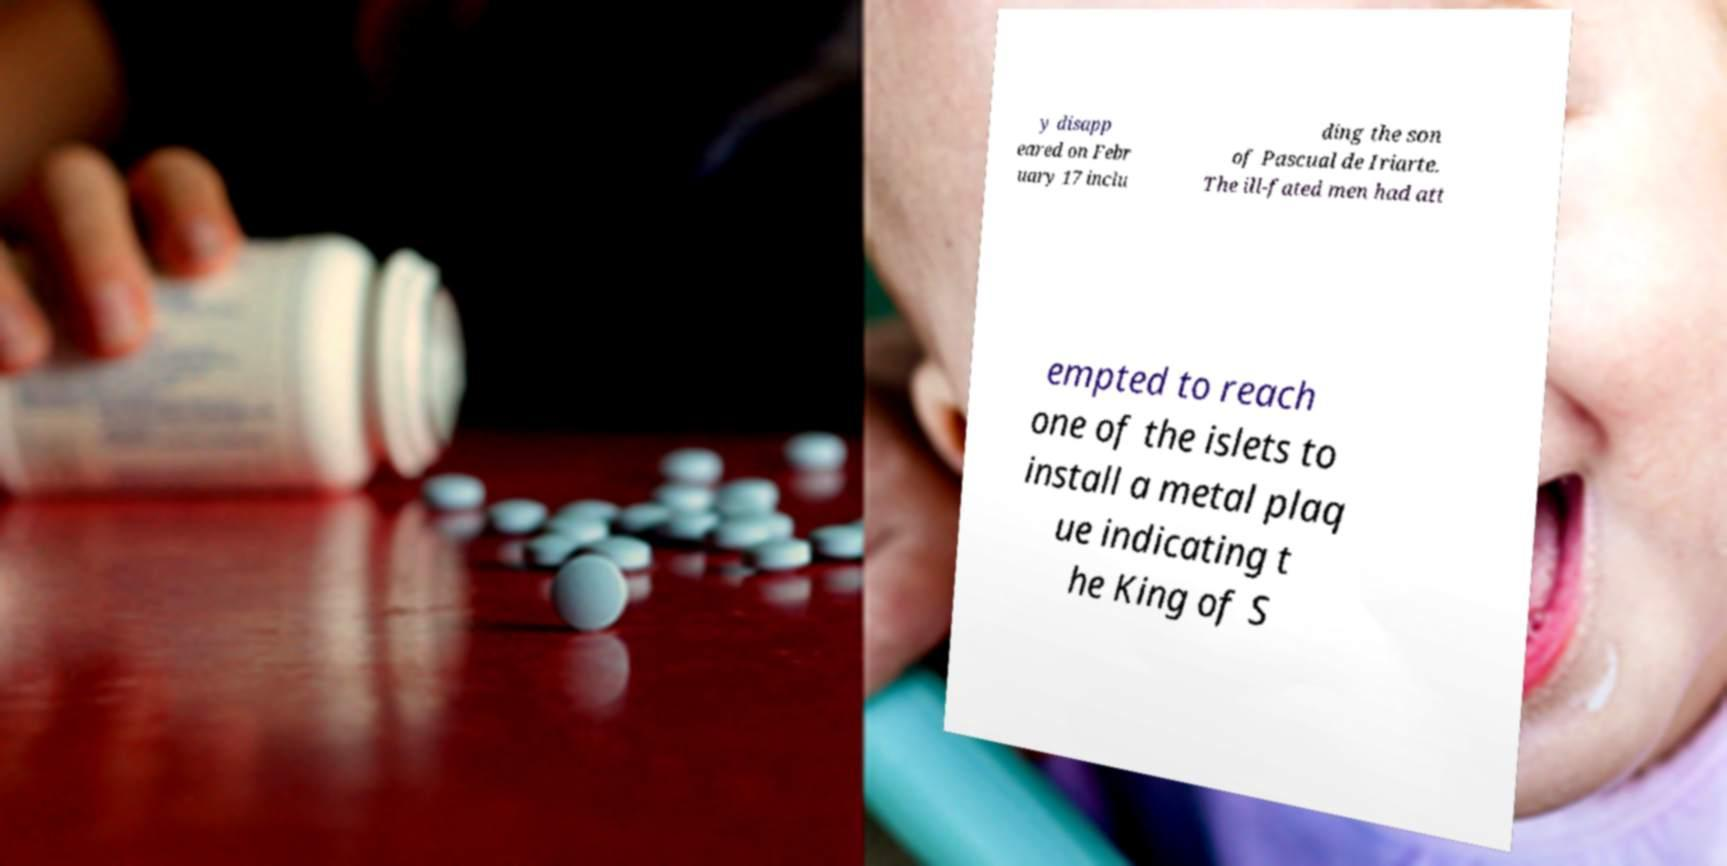Can you read and provide the text displayed in the image?This photo seems to have some interesting text. Can you extract and type it out for me? y disapp eared on Febr uary 17 inclu ding the son of Pascual de Iriarte. The ill-fated men had att empted to reach one of the islets to install a metal plaq ue indicating t he King of S 